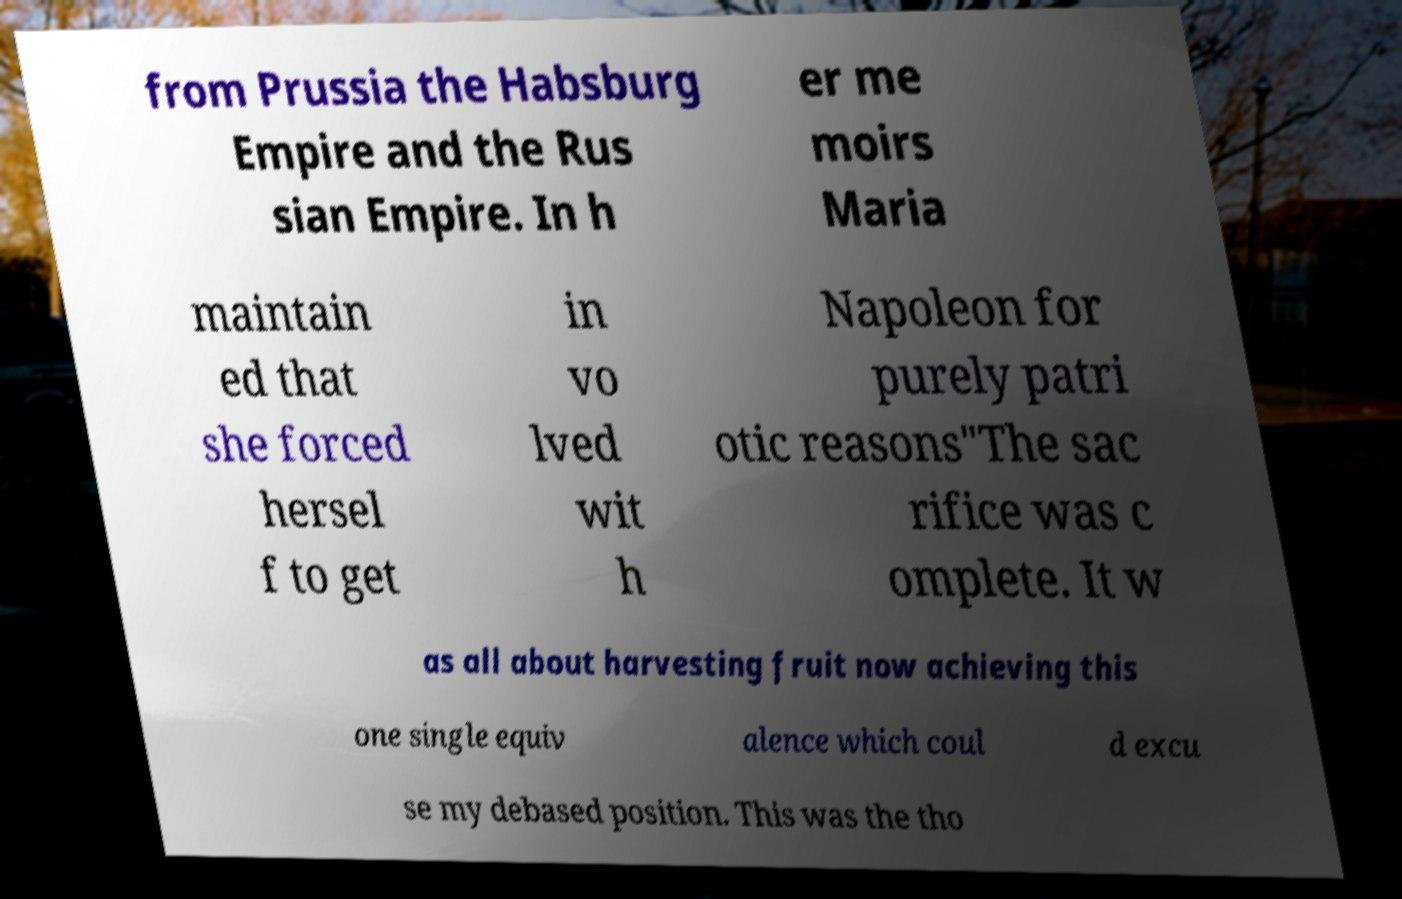What messages or text are displayed in this image? I need them in a readable, typed format. from Prussia the Habsburg Empire and the Rus sian Empire. In h er me moirs Maria maintain ed that she forced hersel f to get in vo lved wit h Napoleon for purely patri otic reasons"The sac rifice was c omplete. It w as all about harvesting fruit now achieving this one single equiv alence which coul d excu se my debased position. This was the tho 